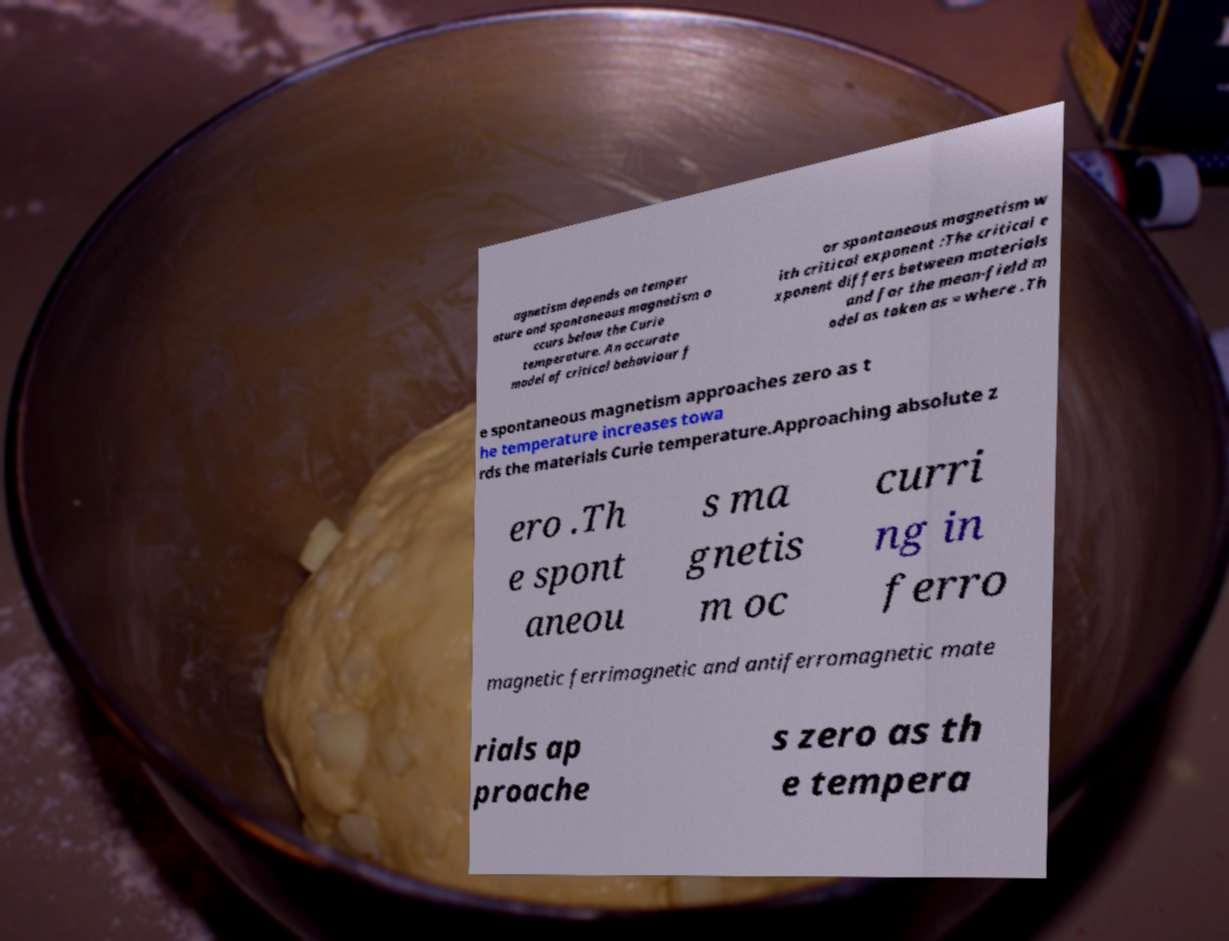Can you read and provide the text displayed in the image?This photo seems to have some interesting text. Can you extract and type it out for me? agnetism depends on temper ature and spontaneous magnetism o ccurs below the Curie temperature. An accurate model of critical behaviour f or spontaneous magnetism w ith critical exponent :The critical e xponent differs between materials and for the mean-field m odel as taken as = where .Th e spontaneous magnetism approaches zero as t he temperature increases towa rds the materials Curie temperature.Approaching absolute z ero .Th e spont aneou s ma gnetis m oc curri ng in ferro magnetic ferrimagnetic and antiferromagnetic mate rials ap proache s zero as th e tempera 